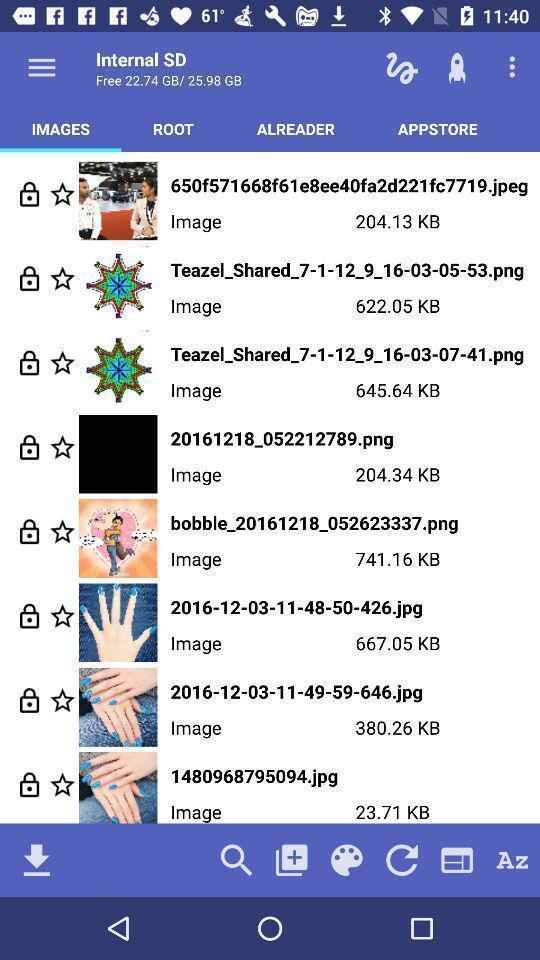Provide a detailed account of this screenshot. Page has list of images. 